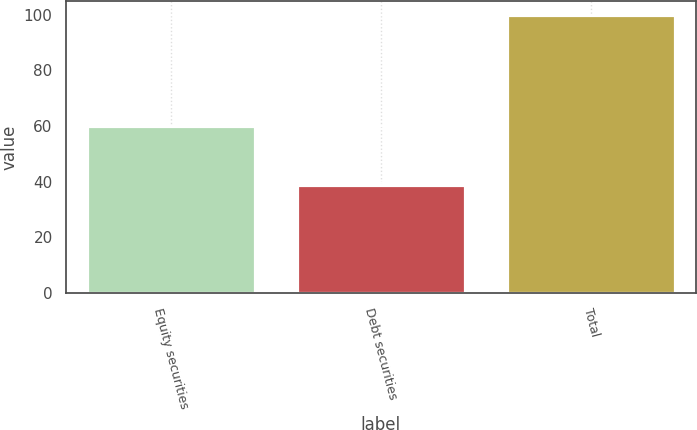Convert chart. <chart><loc_0><loc_0><loc_500><loc_500><bar_chart><fcel>Equity securities<fcel>Debt securities<fcel>Total<nl><fcel>60<fcel>39<fcel>100<nl></chart> 